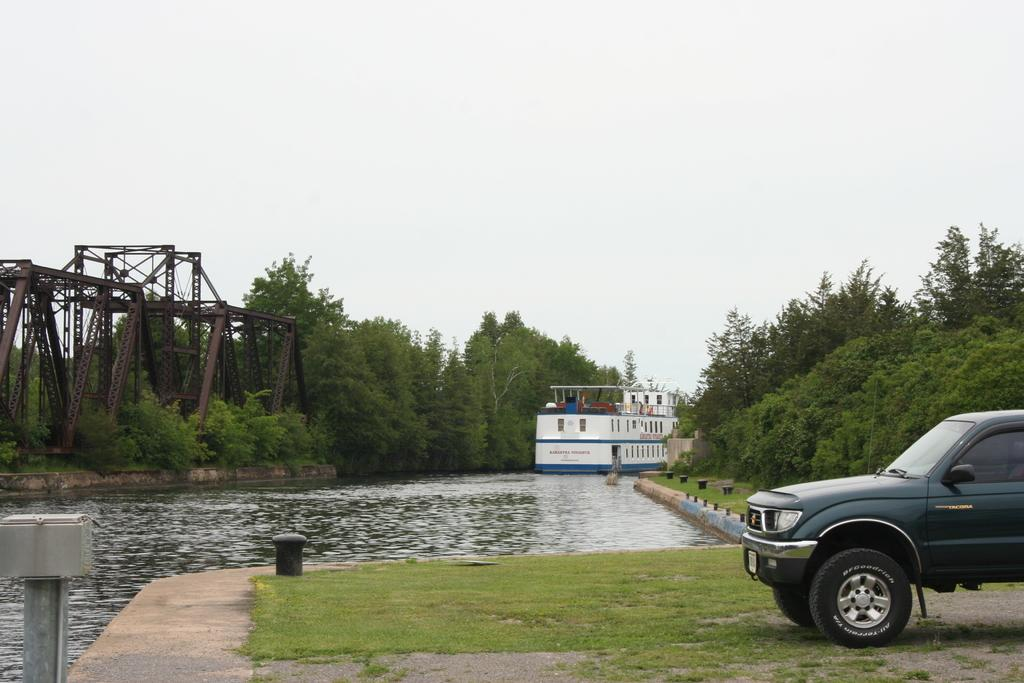What is the main subject of the image? The main subject of the image is a ship. Where is the ship located in the image? The ship is on the water in the image. What can be seen in the background of the image? In the background of the image, there are rods, trees, and poles. What else is present in the image besides the ship? There is a vehicle on the ground and the sky is visible at the top of the image. What is the caption of the image? There is no caption present in the image. How many pans are visible in the image? There are no pans visible in the image. 